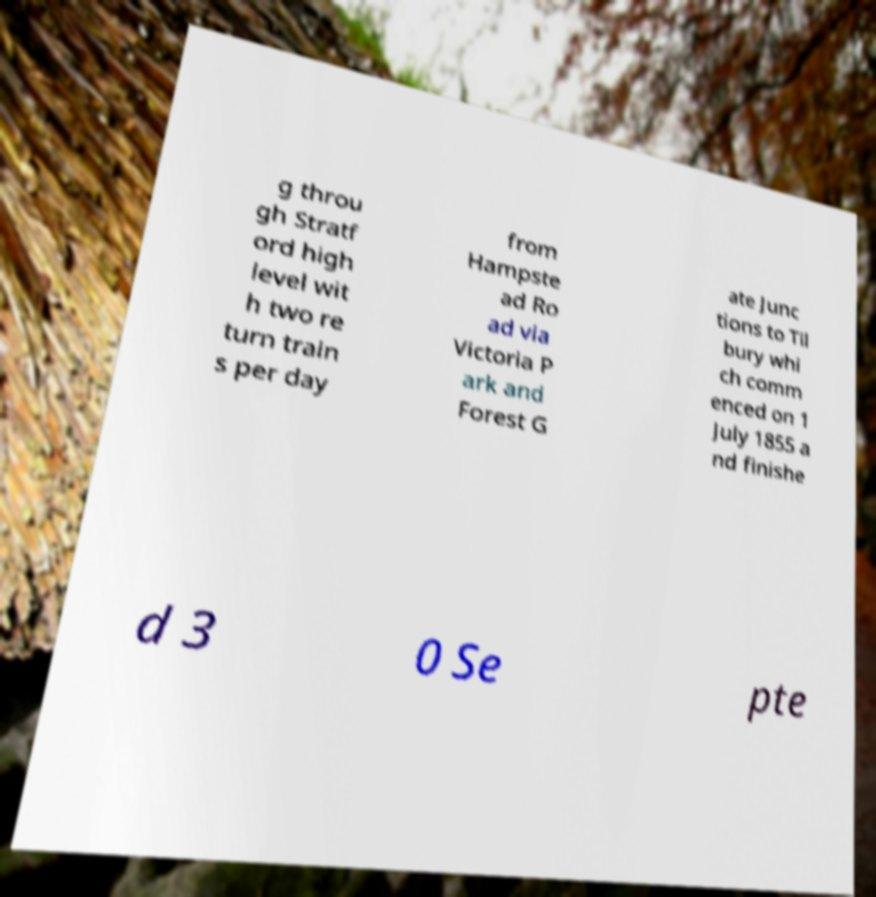Please read and relay the text visible in this image. What does it say? g throu gh Stratf ord high level wit h two re turn train s per day from Hampste ad Ro ad via Victoria P ark and Forest G ate Junc tions to Til bury whi ch comm enced on 1 July 1855 a nd finishe d 3 0 Se pte 